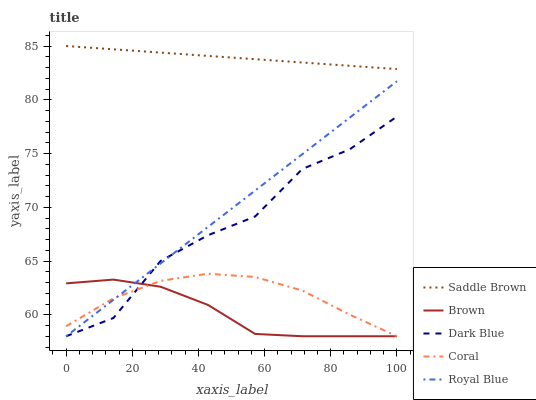Does Coral have the minimum area under the curve?
Answer yes or no. No. Does Coral have the maximum area under the curve?
Answer yes or no. No. Is Coral the smoothest?
Answer yes or no. No. Is Coral the roughest?
Answer yes or no. No. Does Saddle Brown have the lowest value?
Answer yes or no. No. Does Coral have the highest value?
Answer yes or no. No. Is Royal Blue less than Saddle Brown?
Answer yes or no. Yes. Is Saddle Brown greater than Brown?
Answer yes or no. Yes. Does Royal Blue intersect Saddle Brown?
Answer yes or no. No. 